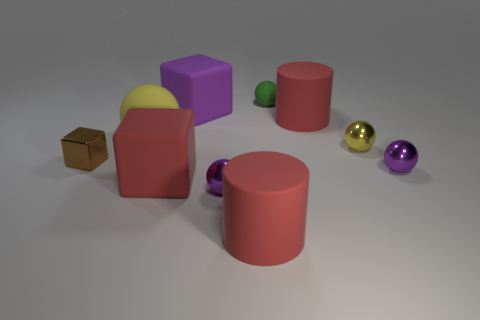Is the number of small green rubber balls behind the purple matte cube less than the number of metallic blocks that are on the left side of the small yellow metallic object?
Your answer should be compact. No. What is the shape of the large rubber object that is both right of the purple rubber thing and to the left of the green sphere?
Give a very brief answer. Cylinder. How many other rubber objects have the same shape as the green thing?
Your answer should be very brief. 1. There is a red cube that is the same material as the large yellow sphere; what is its size?
Your answer should be compact. Large. What number of yellow balls are the same size as the purple rubber object?
Provide a short and direct response. 1. What color is the small metal sphere right of the yellow sphere that is on the right side of the red rubber block?
Your answer should be compact. Purple. Is there a metal thing of the same color as the big ball?
Offer a very short reply. Yes. The rubber object that is the same size as the brown metallic cube is what color?
Keep it short and to the point. Green. Are the large red object to the left of the large purple block and the brown block made of the same material?
Your response must be concise. No. There is a red rubber cylinder in front of the large cylinder behind the large red cube; are there any cylinders left of it?
Make the answer very short. No. 